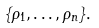<formula> <loc_0><loc_0><loc_500><loc_500>\{ \rho _ { 1 } , \dots , \rho _ { n } \} .</formula> 